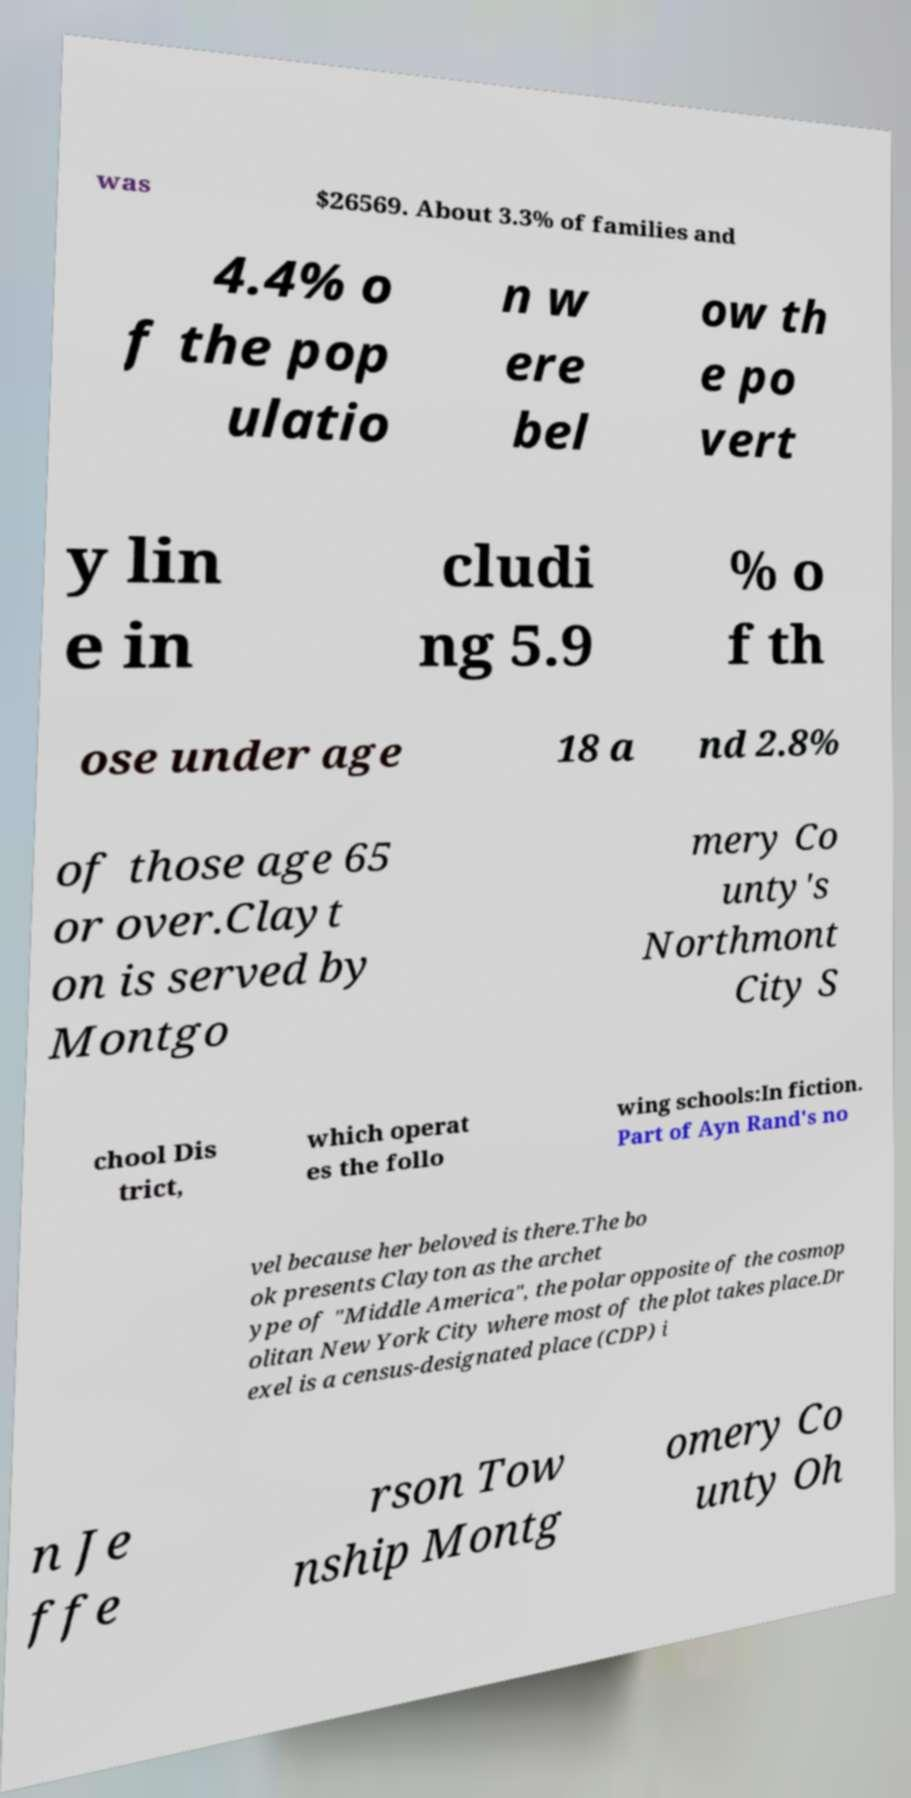There's text embedded in this image that I need extracted. Can you transcribe it verbatim? was $26569. About 3.3% of families and 4.4% o f the pop ulatio n w ere bel ow th e po vert y lin e in cludi ng 5.9 % o f th ose under age 18 a nd 2.8% of those age 65 or over.Clayt on is served by Montgo mery Co unty's Northmont City S chool Dis trict, which operat es the follo wing schools:In fiction. Part of Ayn Rand's no vel because her beloved is there.The bo ok presents Clayton as the archet ype of "Middle America", the polar opposite of the cosmop olitan New York City where most of the plot takes place.Dr exel is a census-designated place (CDP) i n Je ffe rson Tow nship Montg omery Co unty Oh 